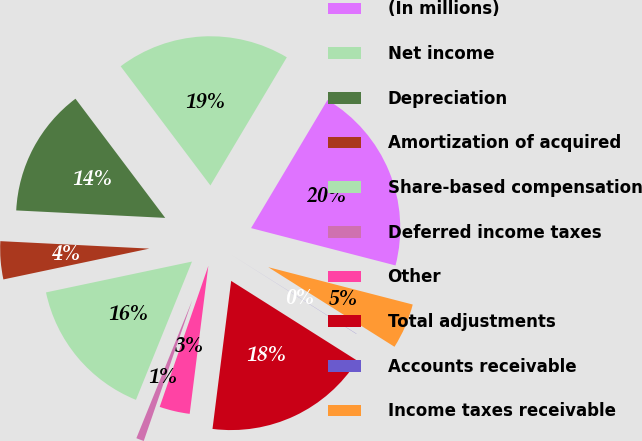Convert chart to OTSL. <chart><loc_0><loc_0><loc_500><loc_500><pie_chart><fcel>(In millions)<fcel>Net income<fcel>Depreciation<fcel>Amortization of acquired<fcel>Share-based compensation<fcel>Deferred income taxes<fcel>Other<fcel>Total adjustments<fcel>Accounts receivable<fcel>Income taxes receivable<nl><fcel>20.47%<fcel>18.83%<fcel>13.93%<fcel>4.11%<fcel>15.56%<fcel>0.84%<fcel>3.29%<fcel>18.02%<fcel>0.02%<fcel>4.93%<nl></chart> 